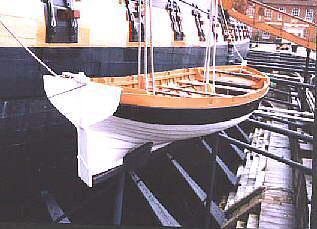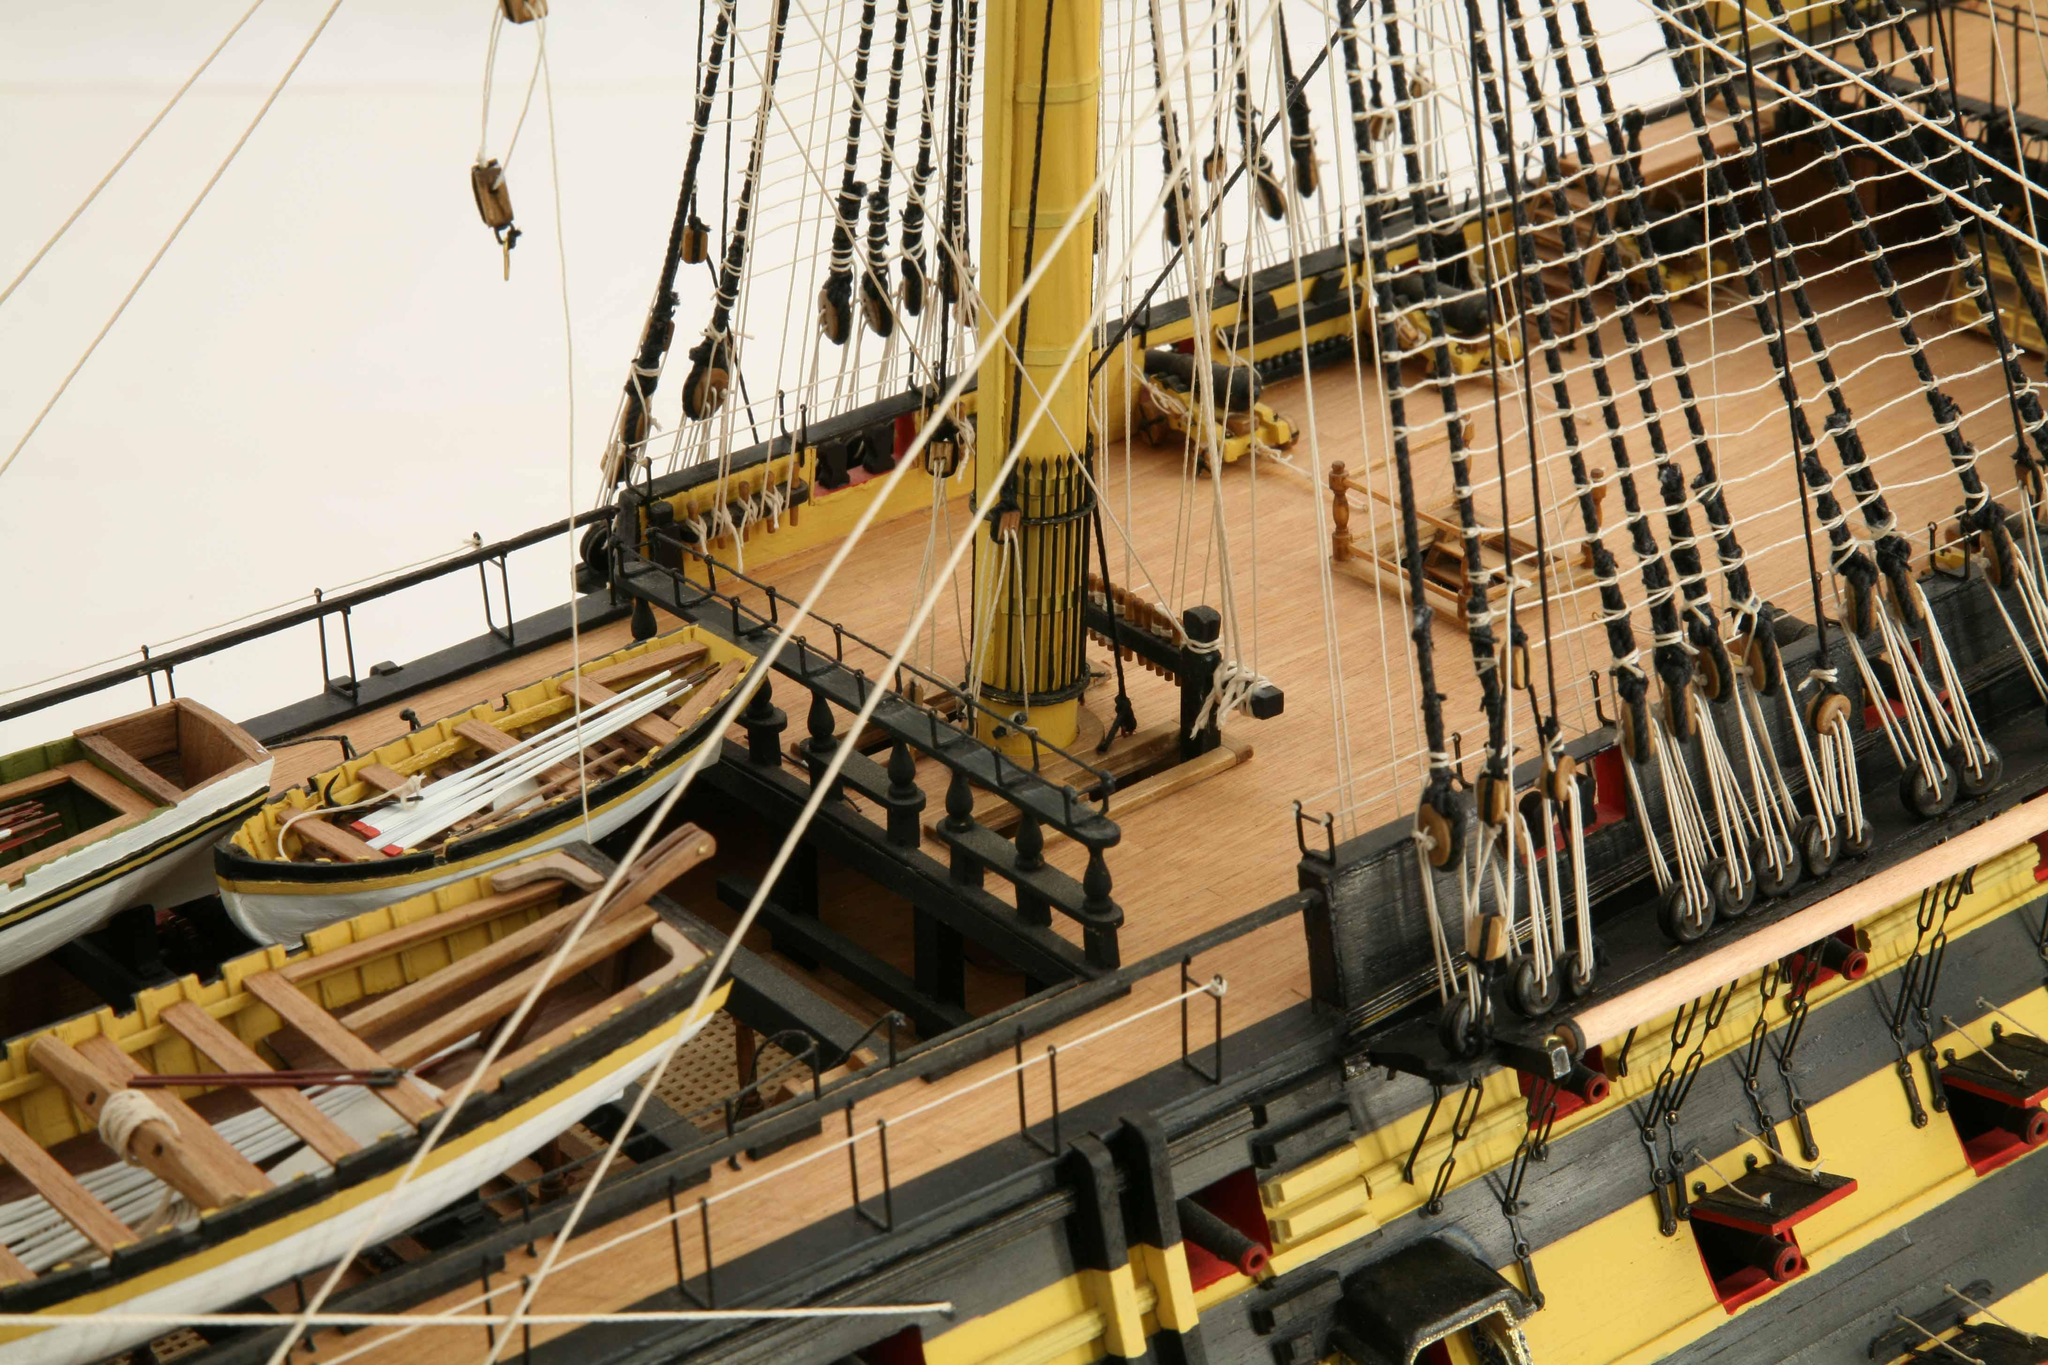The first image is the image on the left, the second image is the image on the right. Given the left and right images, does the statement "An image shows one white-bottomed boat on the exterior side of a ship, below a line of square ports." hold true? Answer yes or no. Yes. The first image is the image on the left, the second image is the image on the right. Evaluate the accuracy of this statement regarding the images: "At least one image shows re-enactors, people wearing period clothing, on or near a boat.". Is it true? Answer yes or no. No. 